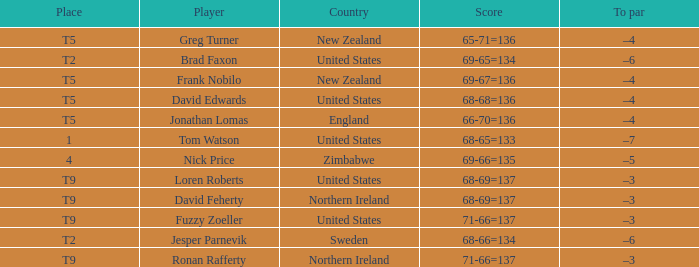The golfer in place 1 if from what country? United States. 